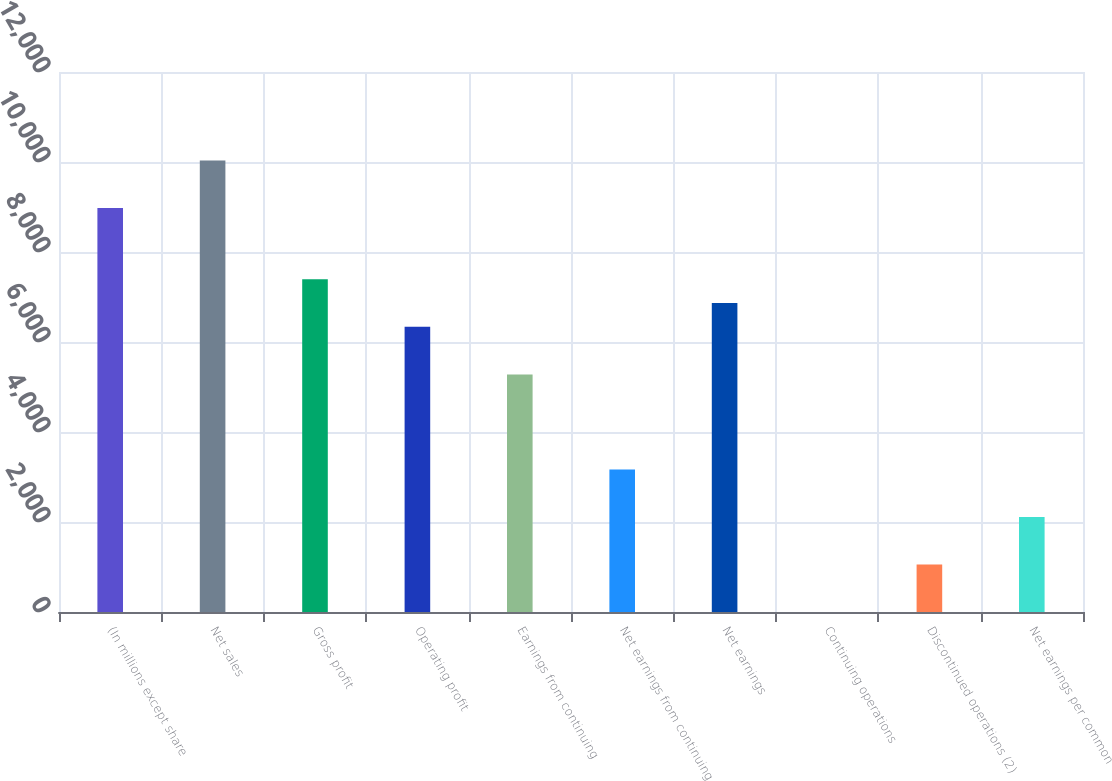<chart> <loc_0><loc_0><loc_500><loc_500><bar_chart><fcel>(In millions except share<fcel>Net sales<fcel>Gross profit<fcel>Operating profit<fcel>Earnings from continuing<fcel>Net earnings from continuing<fcel>Net earnings<fcel>Continuing operations<fcel>Discontinued operations (2)<fcel>Net earnings per common<nl><fcel>8976.34<fcel>10032.3<fcel>7392.34<fcel>6336.34<fcel>5280.34<fcel>3168.34<fcel>6864.34<fcel>0.34<fcel>1056.34<fcel>2112.34<nl></chart> 